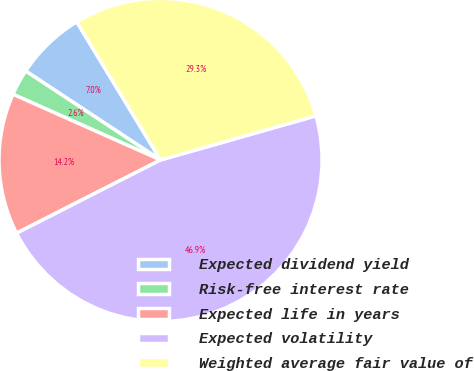Convert chart to OTSL. <chart><loc_0><loc_0><loc_500><loc_500><pie_chart><fcel>Expected dividend yield<fcel>Risk-free interest rate<fcel>Expected life in years<fcel>Expected volatility<fcel>Weighted average fair value of<nl><fcel>7.04%<fcel>2.61%<fcel>14.16%<fcel>46.92%<fcel>29.27%<nl></chart> 